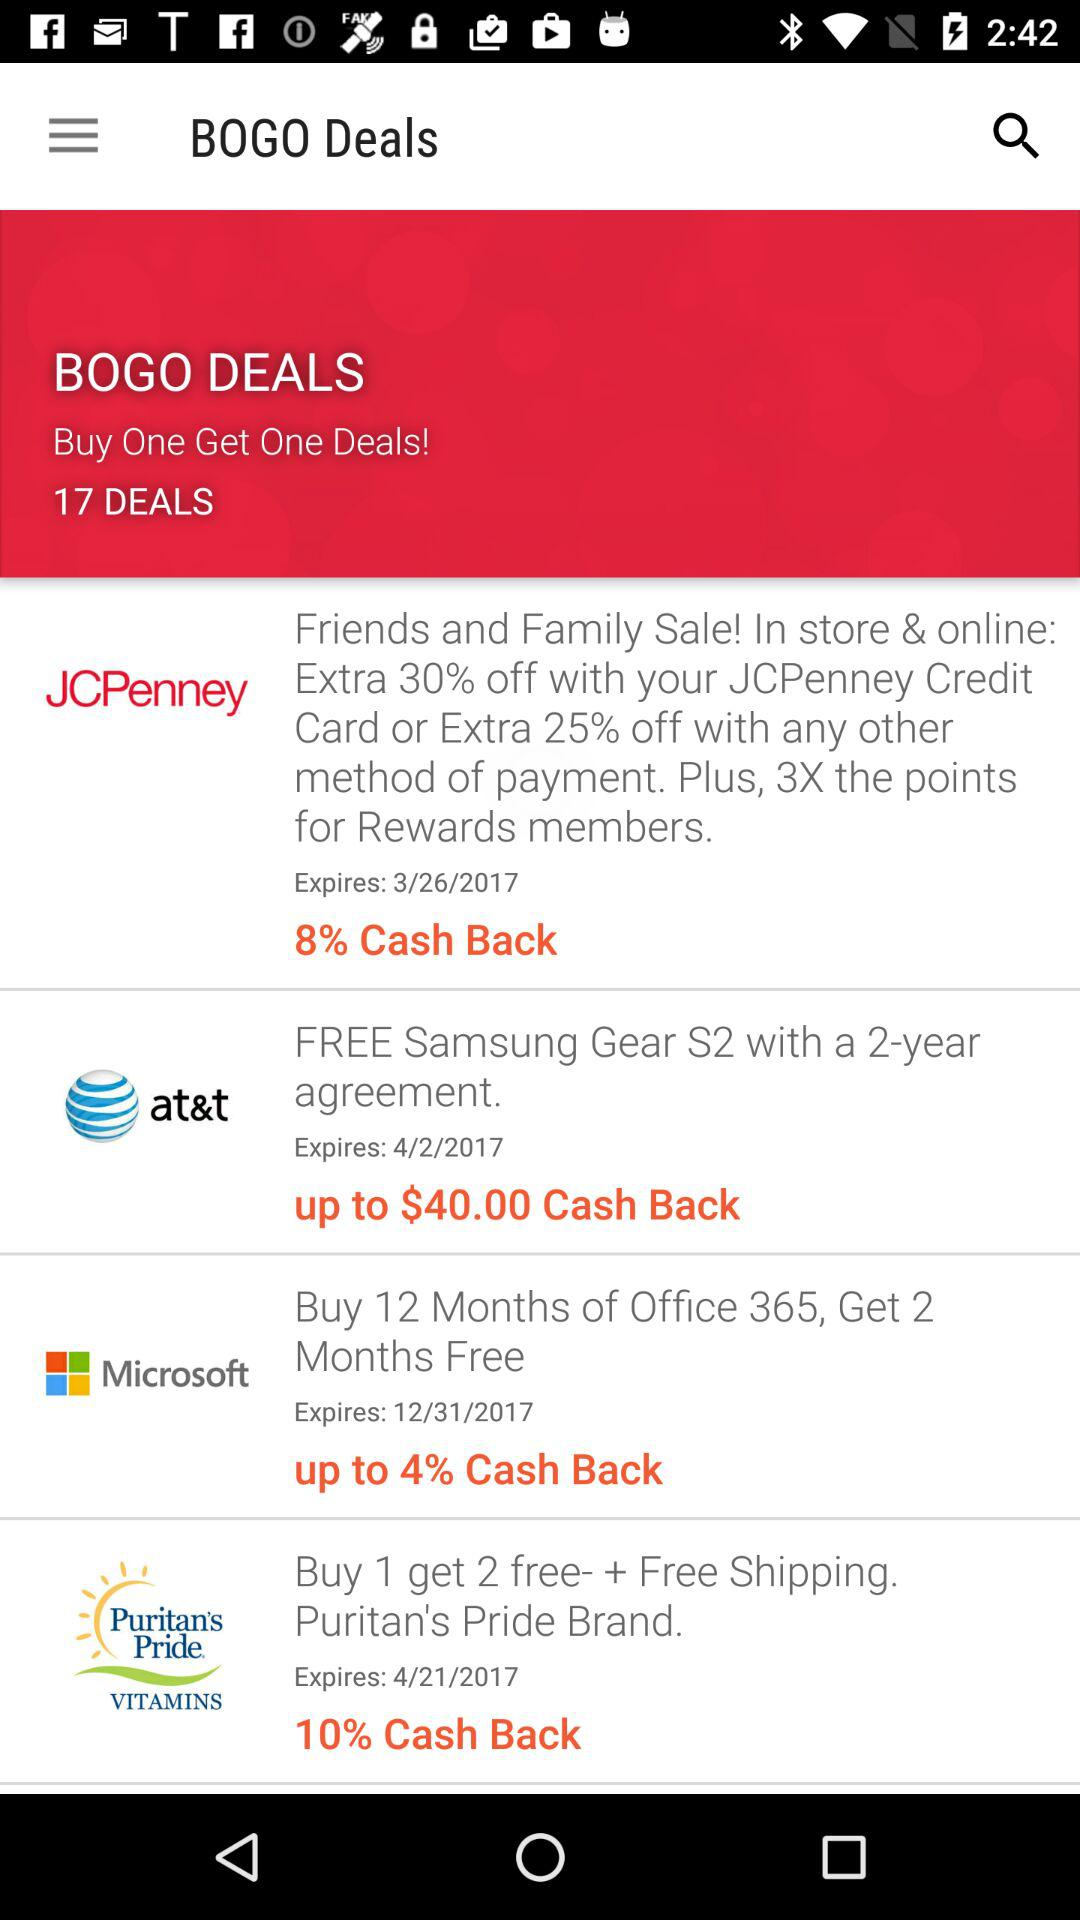What is the highest cash back percentage offered for any of the deals? 10% 